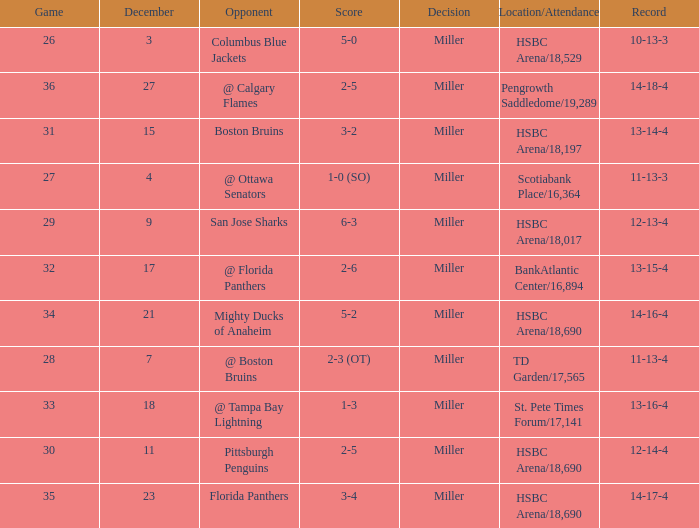Name the opponent for record 10-13-3 Columbus Blue Jackets. 